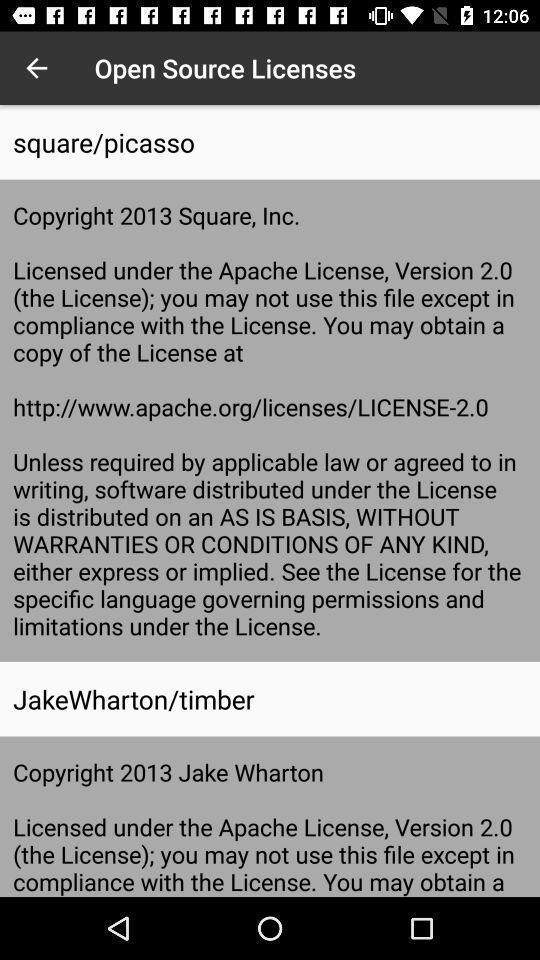Summarize the information in this screenshot. Screen shows about open source licenses. 